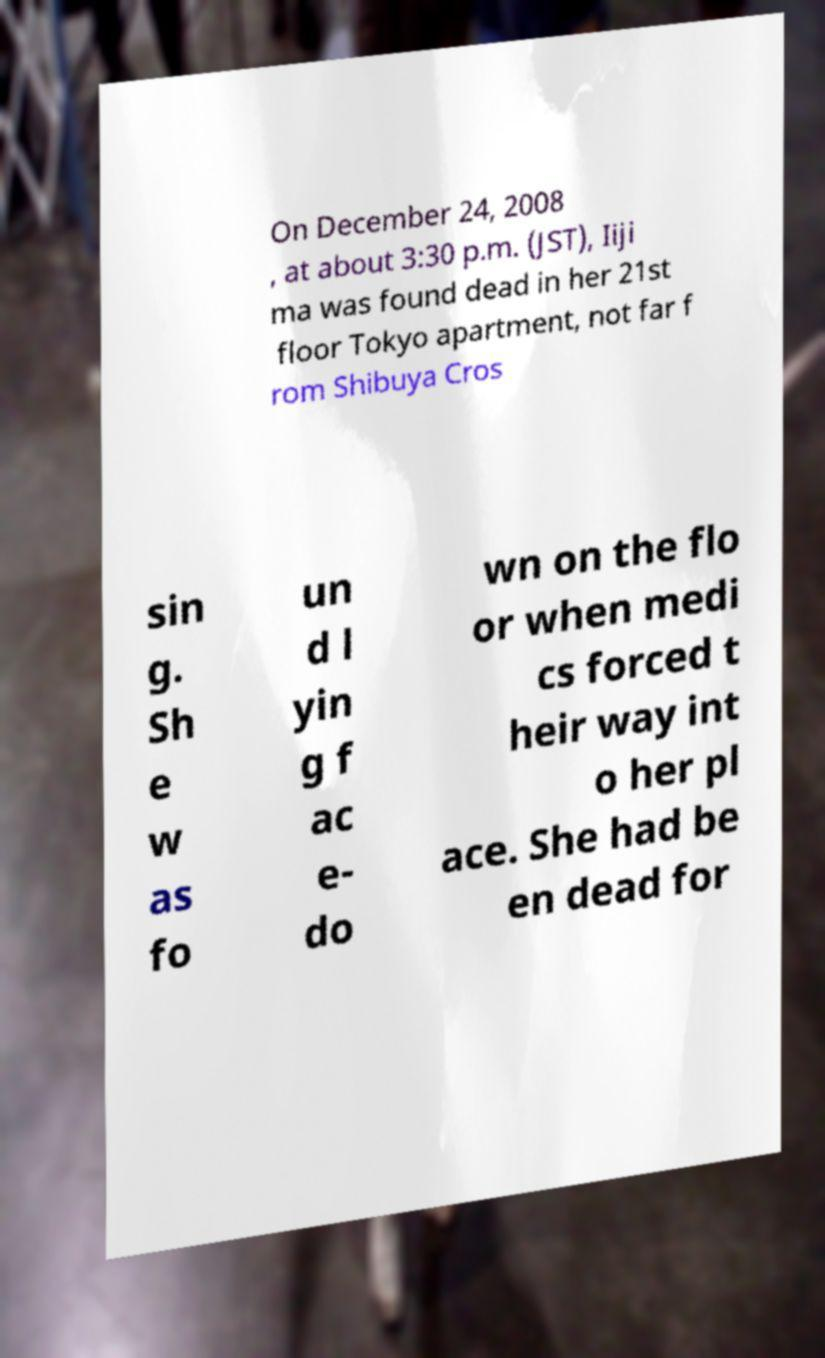Can you read and provide the text displayed in the image?This photo seems to have some interesting text. Can you extract and type it out for me? On December 24, 2008 , at about 3:30 p.m. (JST), Iiji ma was found dead in her 21st floor Tokyo apartment, not far f rom Shibuya Cros sin g. Sh e w as fo un d l yin g f ac e- do wn on the flo or when medi cs forced t heir way int o her pl ace. She had be en dead for 